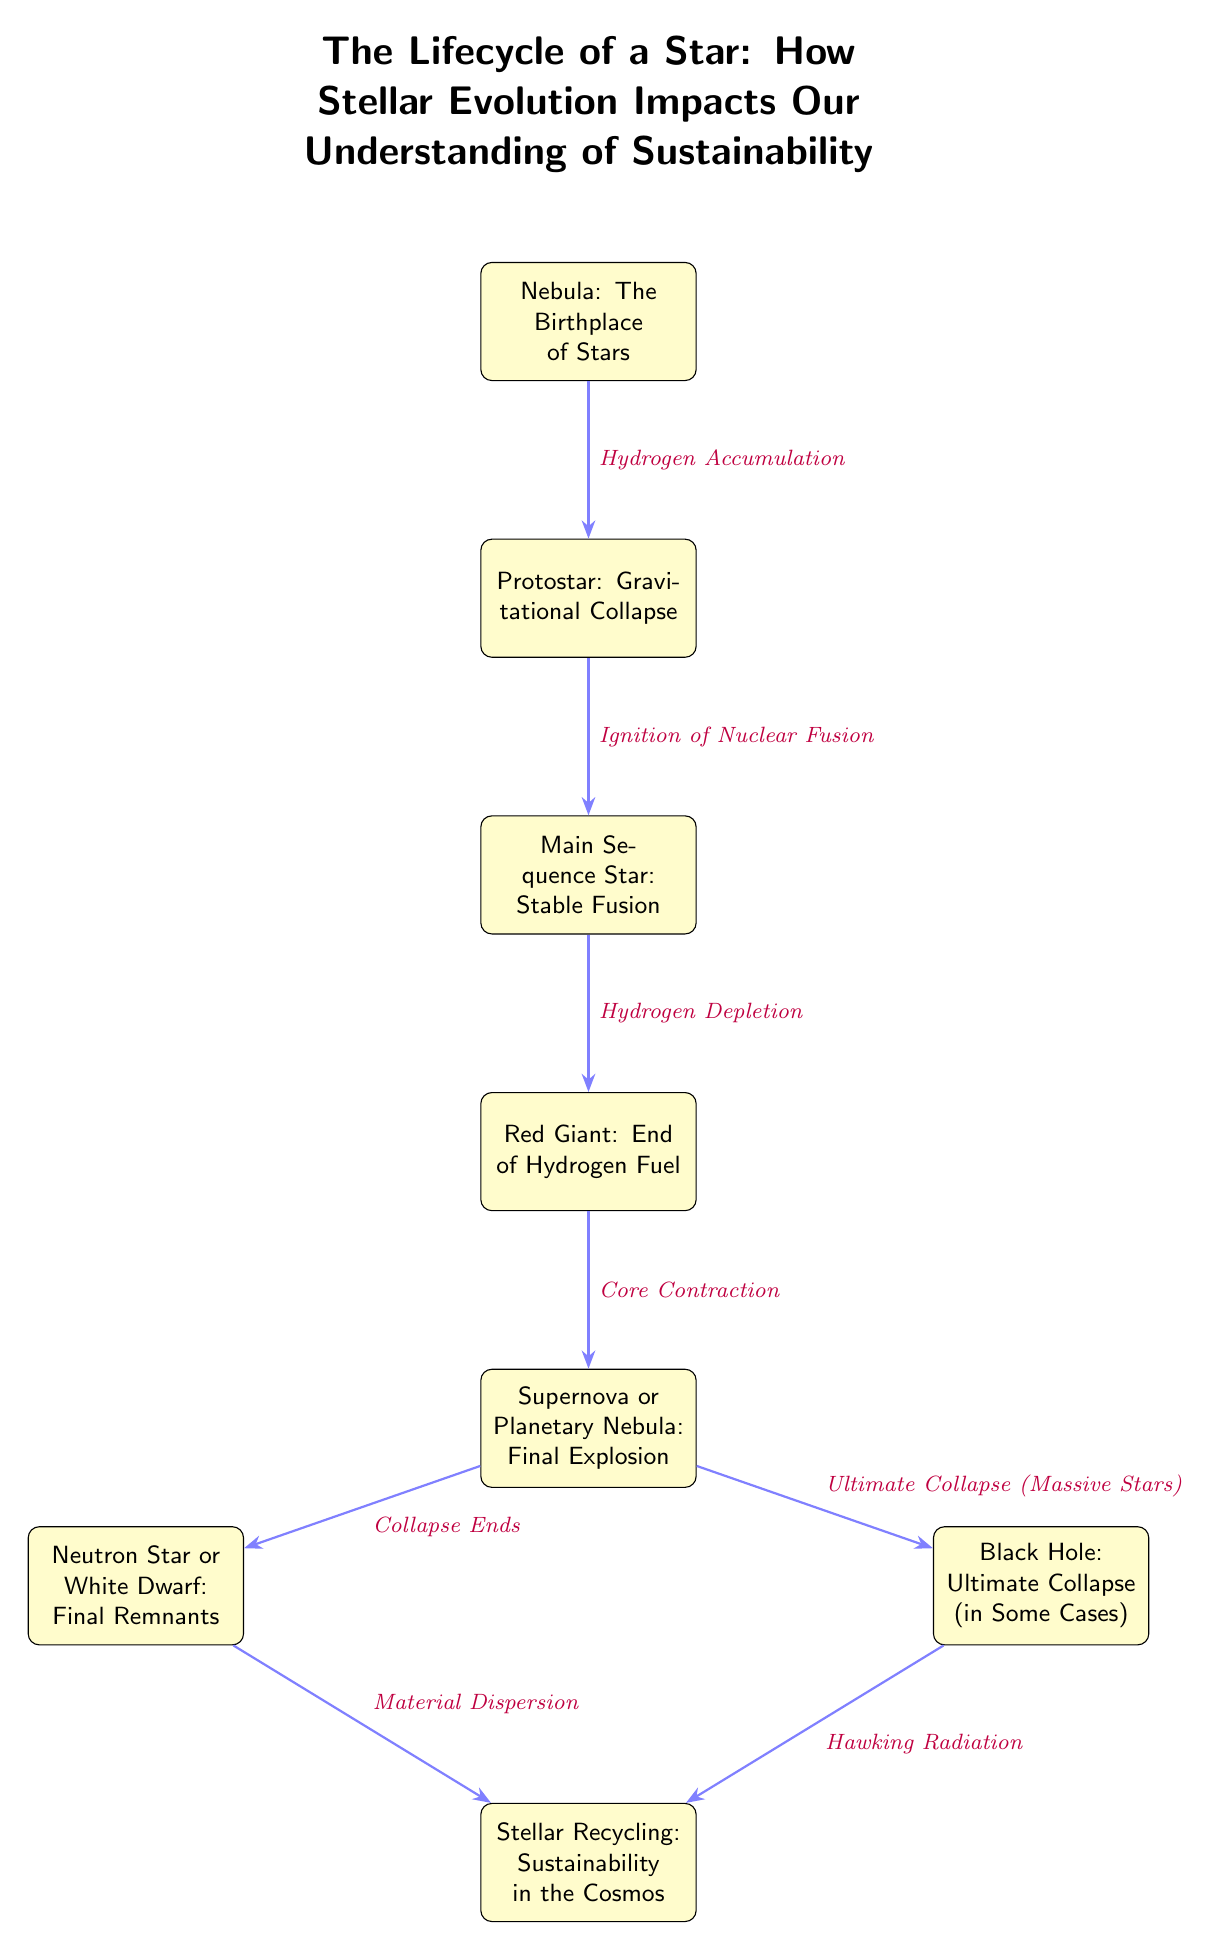What is the first stage of a star's lifecycle? The diagram labels the first stage as "Nebula: The Birthplace of Stars," indicating the starting point in the lifecycle of a star.
Answer: Nebula: The Birthplace of Stars What happens after the protostar stage? From the diagram, the arrow indicates that after the "Protostar: Gravitational Collapse," the next stage is "Main Sequence Star: Stable Fusion."
Answer: Main Sequence Star: Stable Fusion How many final outcomes are shown after the supernova? The diagram shows two outcomes beyond the "Supernova or Planetary Nebula: Final Explosion": "Neutron Star or White Dwarf: Final Remnants" and "Black Hole: Ultimate Collapse (in Some Cases)." This indicates a total of two final outcomes.
Answer: 2 What process initiates the protostar? The diagram states that "Hydrogen Accumulation" leads from the "Nebula" to the "Protostar," indicating that this process is necessary for the transition.
Answer: Hydrogen Accumulation What leads to the recycling phase in the stellar lifecycle? According to the diagram, "Material Dispersion" from the "Neutron Star or White Dwarf: Final Remnants" and "Hawking Radiation" from the "Black Hole: Ultimate Collapse (in Some Cases)" both direct towards "Stellar Recycling: Sustainability in the Cosmos." Therefore, these two processes lead to recycling.
Answer: Material Dispersion and Hawking Radiation What does the main sequence star consume? The diagram indicates that the "Main Sequence Star: Stable Fusion" is the stage where hydrogen is being consumed and converted into helium through nuclear fusion.
Answer: Hydrogen What characterizes the red giant phase? The diagram describes the red giant phase as "Red Giant: End of Hydrogen Fuel," indicating that this stage is defined by the depletion of hydrogen.
Answer: End of Hydrogen Fuel Which nodes are related to the final explosion of a star? The "Supernova or Planetary Nebula: Final Explosion" is directly connected to the "Red Giant: End of Hydrogen Fuel," marking the last explosive phase in stellar evolution before decomposing.
Answer: Supernova or Planetary Nebula: Final Explosion What type of star does the lifecycle conclude with? The diagram highlights that the lifecycle of a star can conclude with either a "Neutron Star or White Dwarf" or a "Black Hole," depending on the mass of the original star.
Answer: Neutron Star or White Dwarf or Black Hole 